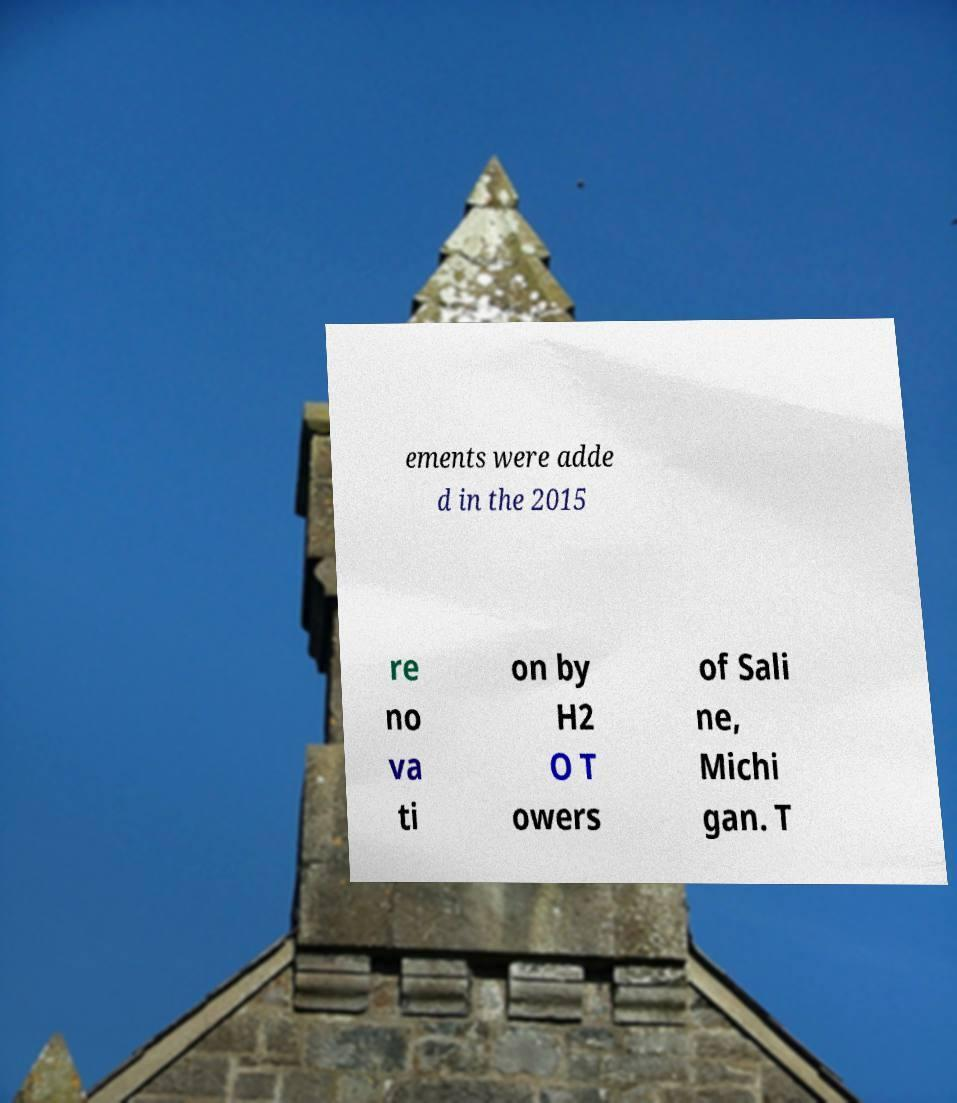There's text embedded in this image that I need extracted. Can you transcribe it verbatim? ements were adde d in the 2015 re no va ti on by H2 O T owers of Sali ne, Michi gan. T 